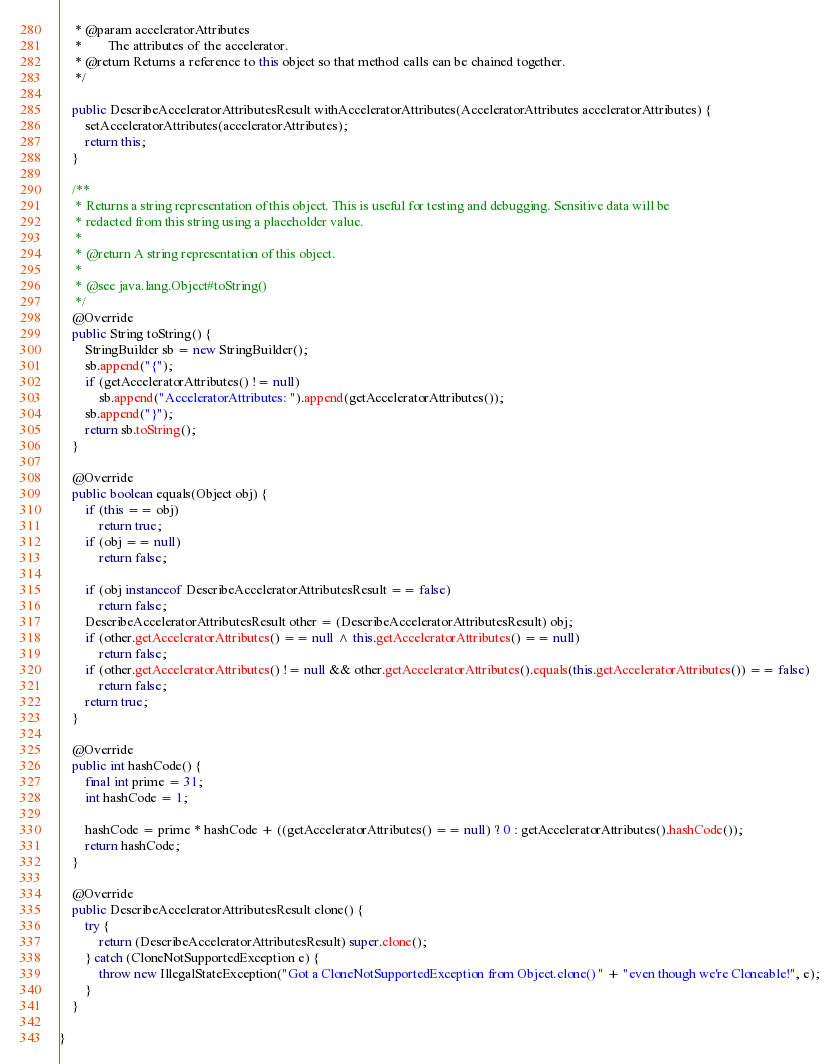<code> <loc_0><loc_0><loc_500><loc_500><_Java_>     * @param acceleratorAttributes
     *        The attributes of the accelerator.
     * @return Returns a reference to this object so that method calls can be chained together.
     */

    public DescribeAcceleratorAttributesResult withAcceleratorAttributes(AcceleratorAttributes acceleratorAttributes) {
        setAcceleratorAttributes(acceleratorAttributes);
        return this;
    }

    /**
     * Returns a string representation of this object. This is useful for testing and debugging. Sensitive data will be
     * redacted from this string using a placeholder value.
     *
     * @return A string representation of this object.
     *
     * @see java.lang.Object#toString()
     */
    @Override
    public String toString() {
        StringBuilder sb = new StringBuilder();
        sb.append("{");
        if (getAcceleratorAttributes() != null)
            sb.append("AcceleratorAttributes: ").append(getAcceleratorAttributes());
        sb.append("}");
        return sb.toString();
    }

    @Override
    public boolean equals(Object obj) {
        if (this == obj)
            return true;
        if (obj == null)
            return false;

        if (obj instanceof DescribeAcceleratorAttributesResult == false)
            return false;
        DescribeAcceleratorAttributesResult other = (DescribeAcceleratorAttributesResult) obj;
        if (other.getAcceleratorAttributes() == null ^ this.getAcceleratorAttributes() == null)
            return false;
        if (other.getAcceleratorAttributes() != null && other.getAcceleratorAttributes().equals(this.getAcceleratorAttributes()) == false)
            return false;
        return true;
    }

    @Override
    public int hashCode() {
        final int prime = 31;
        int hashCode = 1;

        hashCode = prime * hashCode + ((getAcceleratorAttributes() == null) ? 0 : getAcceleratorAttributes().hashCode());
        return hashCode;
    }

    @Override
    public DescribeAcceleratorAttributesResult clone() {
        try {
            return (DescribeAcceleratorAttributesResult) super.clone();
        } catch (CloneNotSupportedException e) {
            throw new IllegalStateException("Got a CloneNotSupportedException from Object.clone() " + "even though we're Cloneable!", e);
        }
    }

}
</code> 